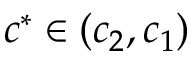Convert formula to latex. <formula><loc_0><loc_0><loc_500><loc_500>c ^ { * } \in ( c _ { 2 } , c _ { 1 } )</formula> 